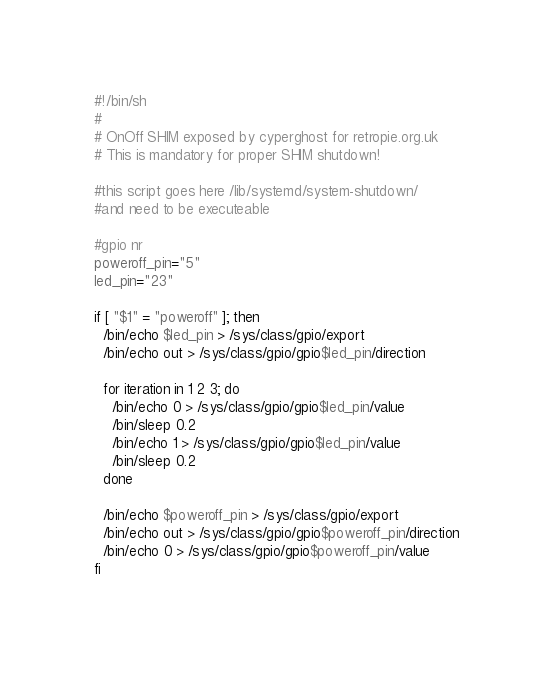Convert code to text. <code><loc_0><loc_0><loc_500><loc_500><_Bash_>#!/bin/sh
#
# OnOff SHIM exposed by cyperghost for retropie.org.uk
# This is mandatory for proper SHIM shutdown!

#this script goes here /lib/systemd/system-shutdown/
#and need to be executeable

#gpio nr
poweroff_pin="5"
led_pin="23"

if [ "$1" = "poweroff" ]; then
  /bin/echo $led_pin > /sys/class/gpio/export
  /bin/echo out > /sys/class/gpio/gpio$led_pin/direction

  for iteration in 1 2 3; do
    /bin/echo 0 > /sys/class/gpio/gpio$led_pin/value
    /bin/sleep 0.2
    /bin/echo 1 > /sys/class/gpio/gpio$led_pin/value
    /bin/sleep 0.2
  done

  /bin/echo $poweroff_pin > /sys/class/gpio/export
  /bin/echo out > /sys/class/gpio/gpio$poweroff_pin/direction
  /bin/echo 0 > /sys/class/gpio/gpio$poweroff_pin/value
fi</code> 